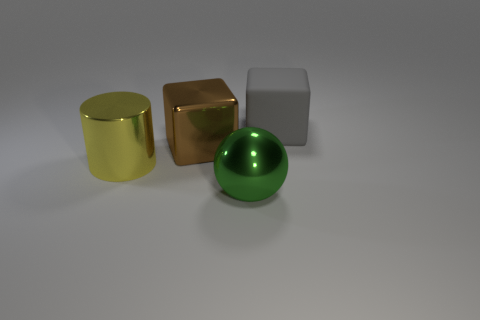Is there a large green object on the right side of the metallic object that is on the right side of the big brown thing?
Your response must be concise. No. What number of things are on the left side of the big brown metal block and right of the big green shiny object?
Give a very brief answer. 0. What number of big gray cubes are the same material as the green thing?
Your response must be concise. 0. There is a cube that is behind the big block that is in front of the matte object; what is its size?
Give a very brief answer. Large. Is there a metallic thing that has the same shape as the large rubber object?
Keep it short and to the point. Yes. Does the block that is left of the big gray matte block have the same size as the shiny object on the left side of the metallic cube?
Offer a terse response. Yes. Is the number of gray rubber things that are on the left side of the yellow cylinder less than the number of gray rubber blocks that are in front of the big metallic ball?
Your response must be concise. No. There is a big cube in front of the gray thing; what color is it?
Your answer should be compact. Brown. Is the color of the metallic ball the same as the large matte object?
Offer a terse response. No. How many big gray rubber cubes are on the left side of the large block in front of the large thing to the right of the sphere?
Keep it short and to the point. 0. 